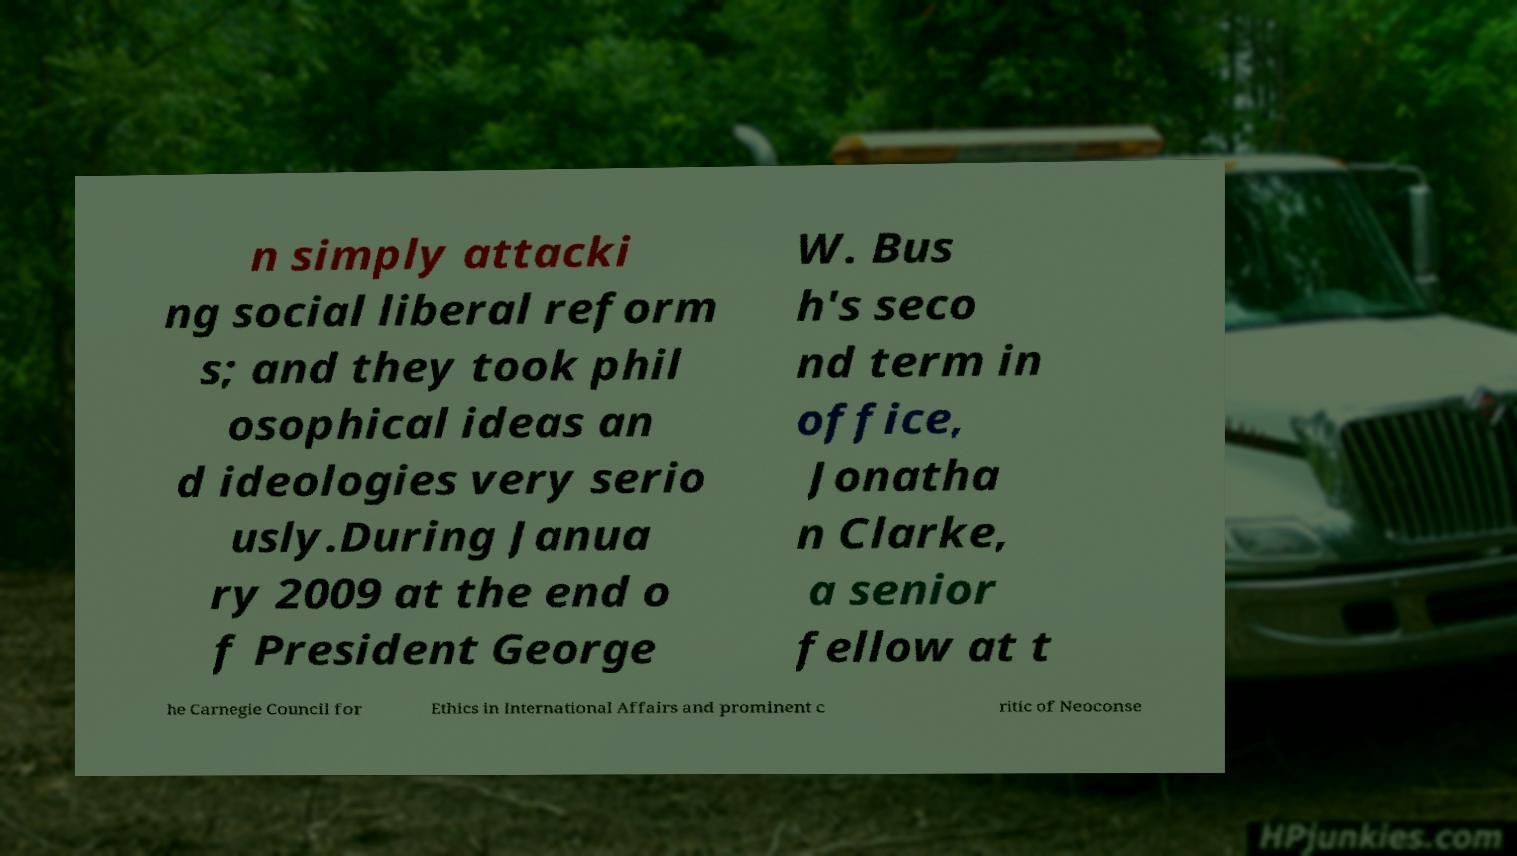There's text embedded in this image that I need extracted. Can you transcribe it verbatim? n simply attacki ng social liberal reform s; and they took phil osophical ideas an d ideologies very serio usly.During Janua ry 2009 at the end o f President George W. Bus h's seco nd term in office, Jonatha n Clarke, a senior fellow at t he Carnegie Council for Ethics in International Affairs and prominent c ritic of Neoconse 